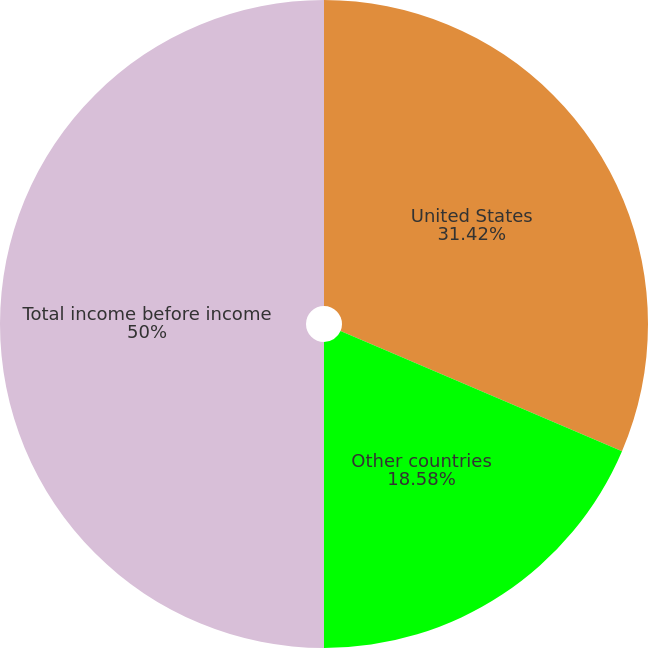Convert chart. <chart><loc_0><loc_0><loc_500><loc_500><pie_chart><fcel>United States<fcel>Other countries<fcel>Total income before income<nl><fcel>31.42%<fcel>18.58%<fcel>50.0%<nl></chart> 